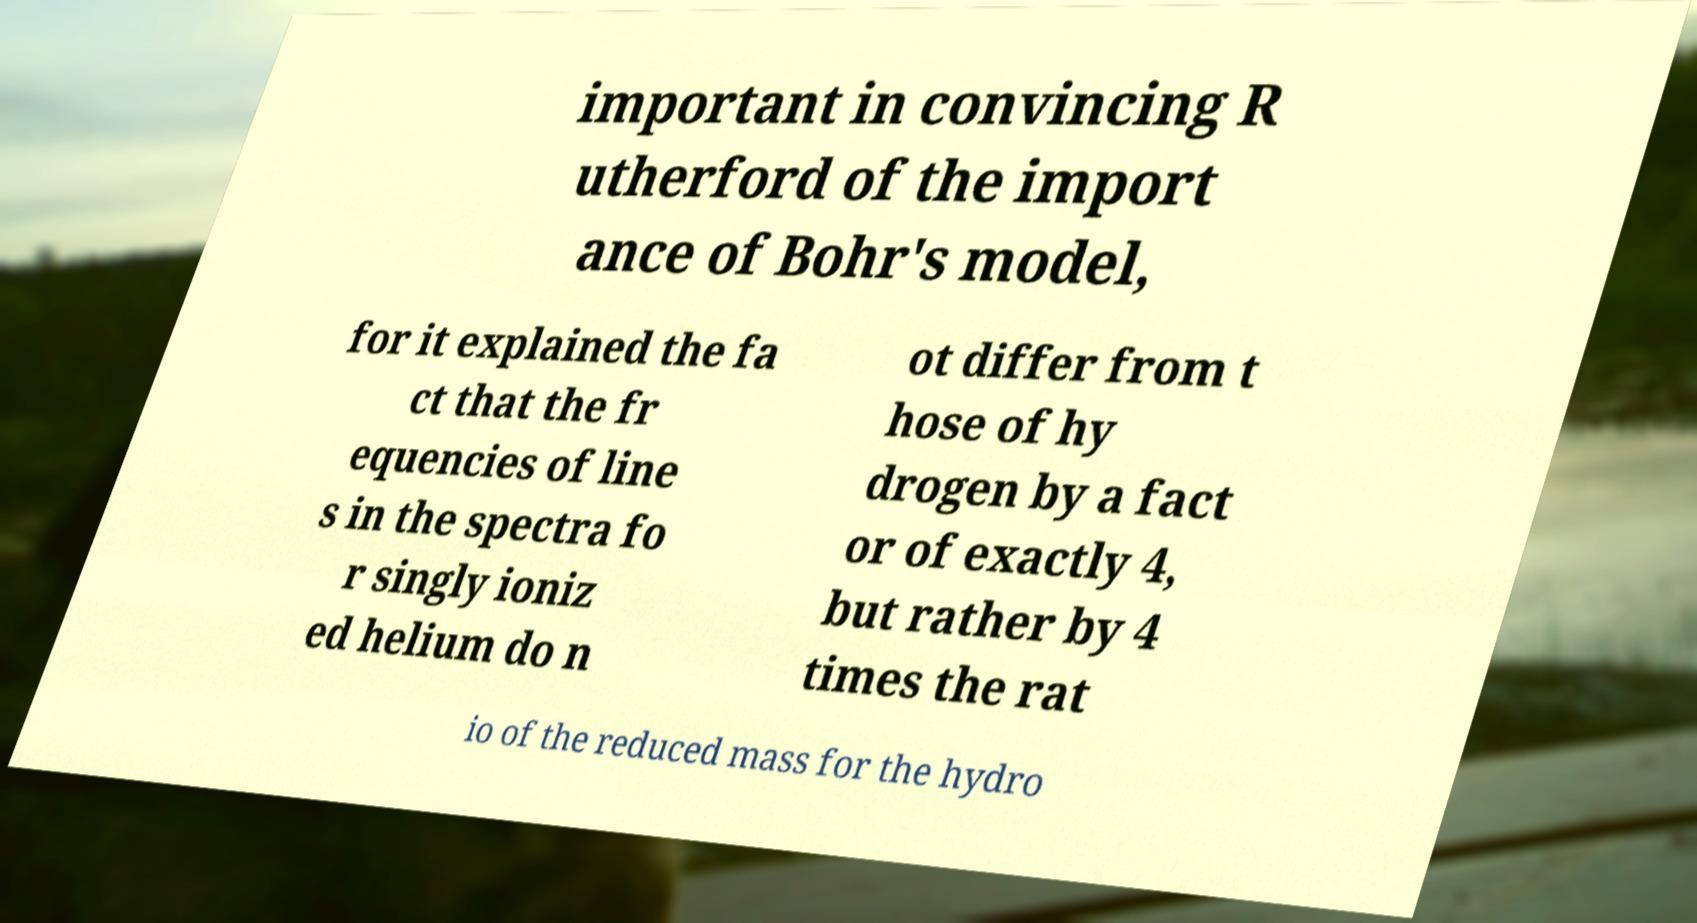Can you accurately transcribe the text from the provided image for me? important in convincing R utherford of the import ance of Bohr's model, for it explained the fa ct that the fr equencies of line s in the spectra fo r singly ioniz ed helium do n ot differ from t hose of hy drogen by a fact or of exactly 4, but rather by 4 times the rat io of the reduced mass for the hydro 